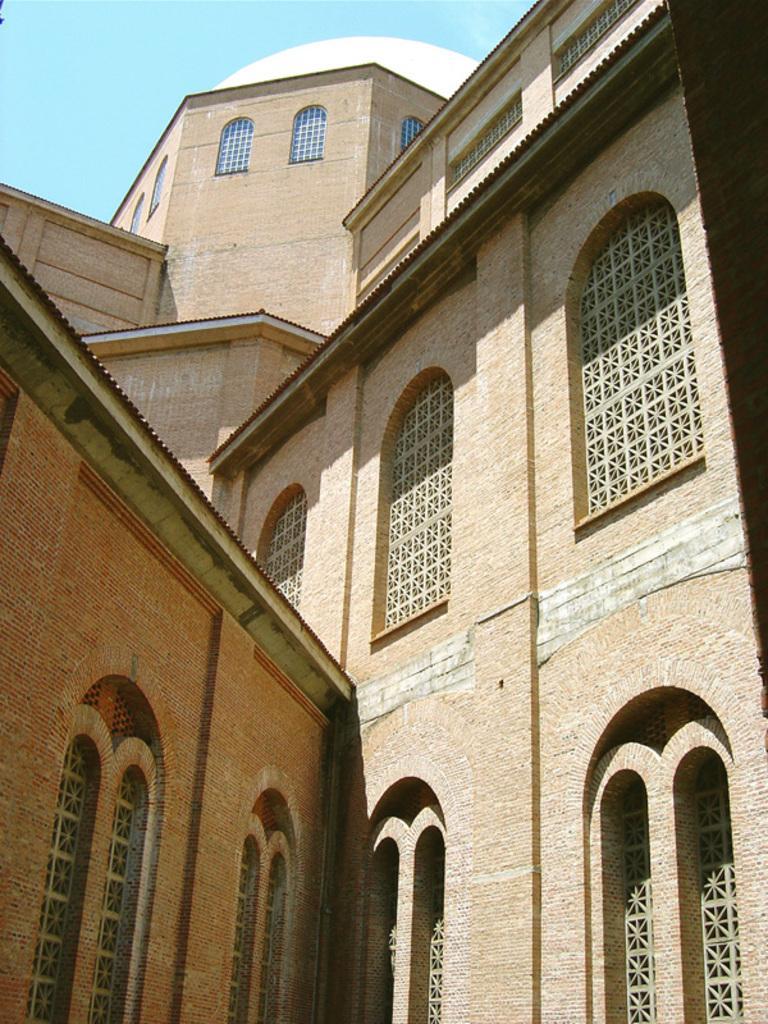Describe this image in one or two sentences. In this image we can see a building with arches and windows. At the top there is sky. 